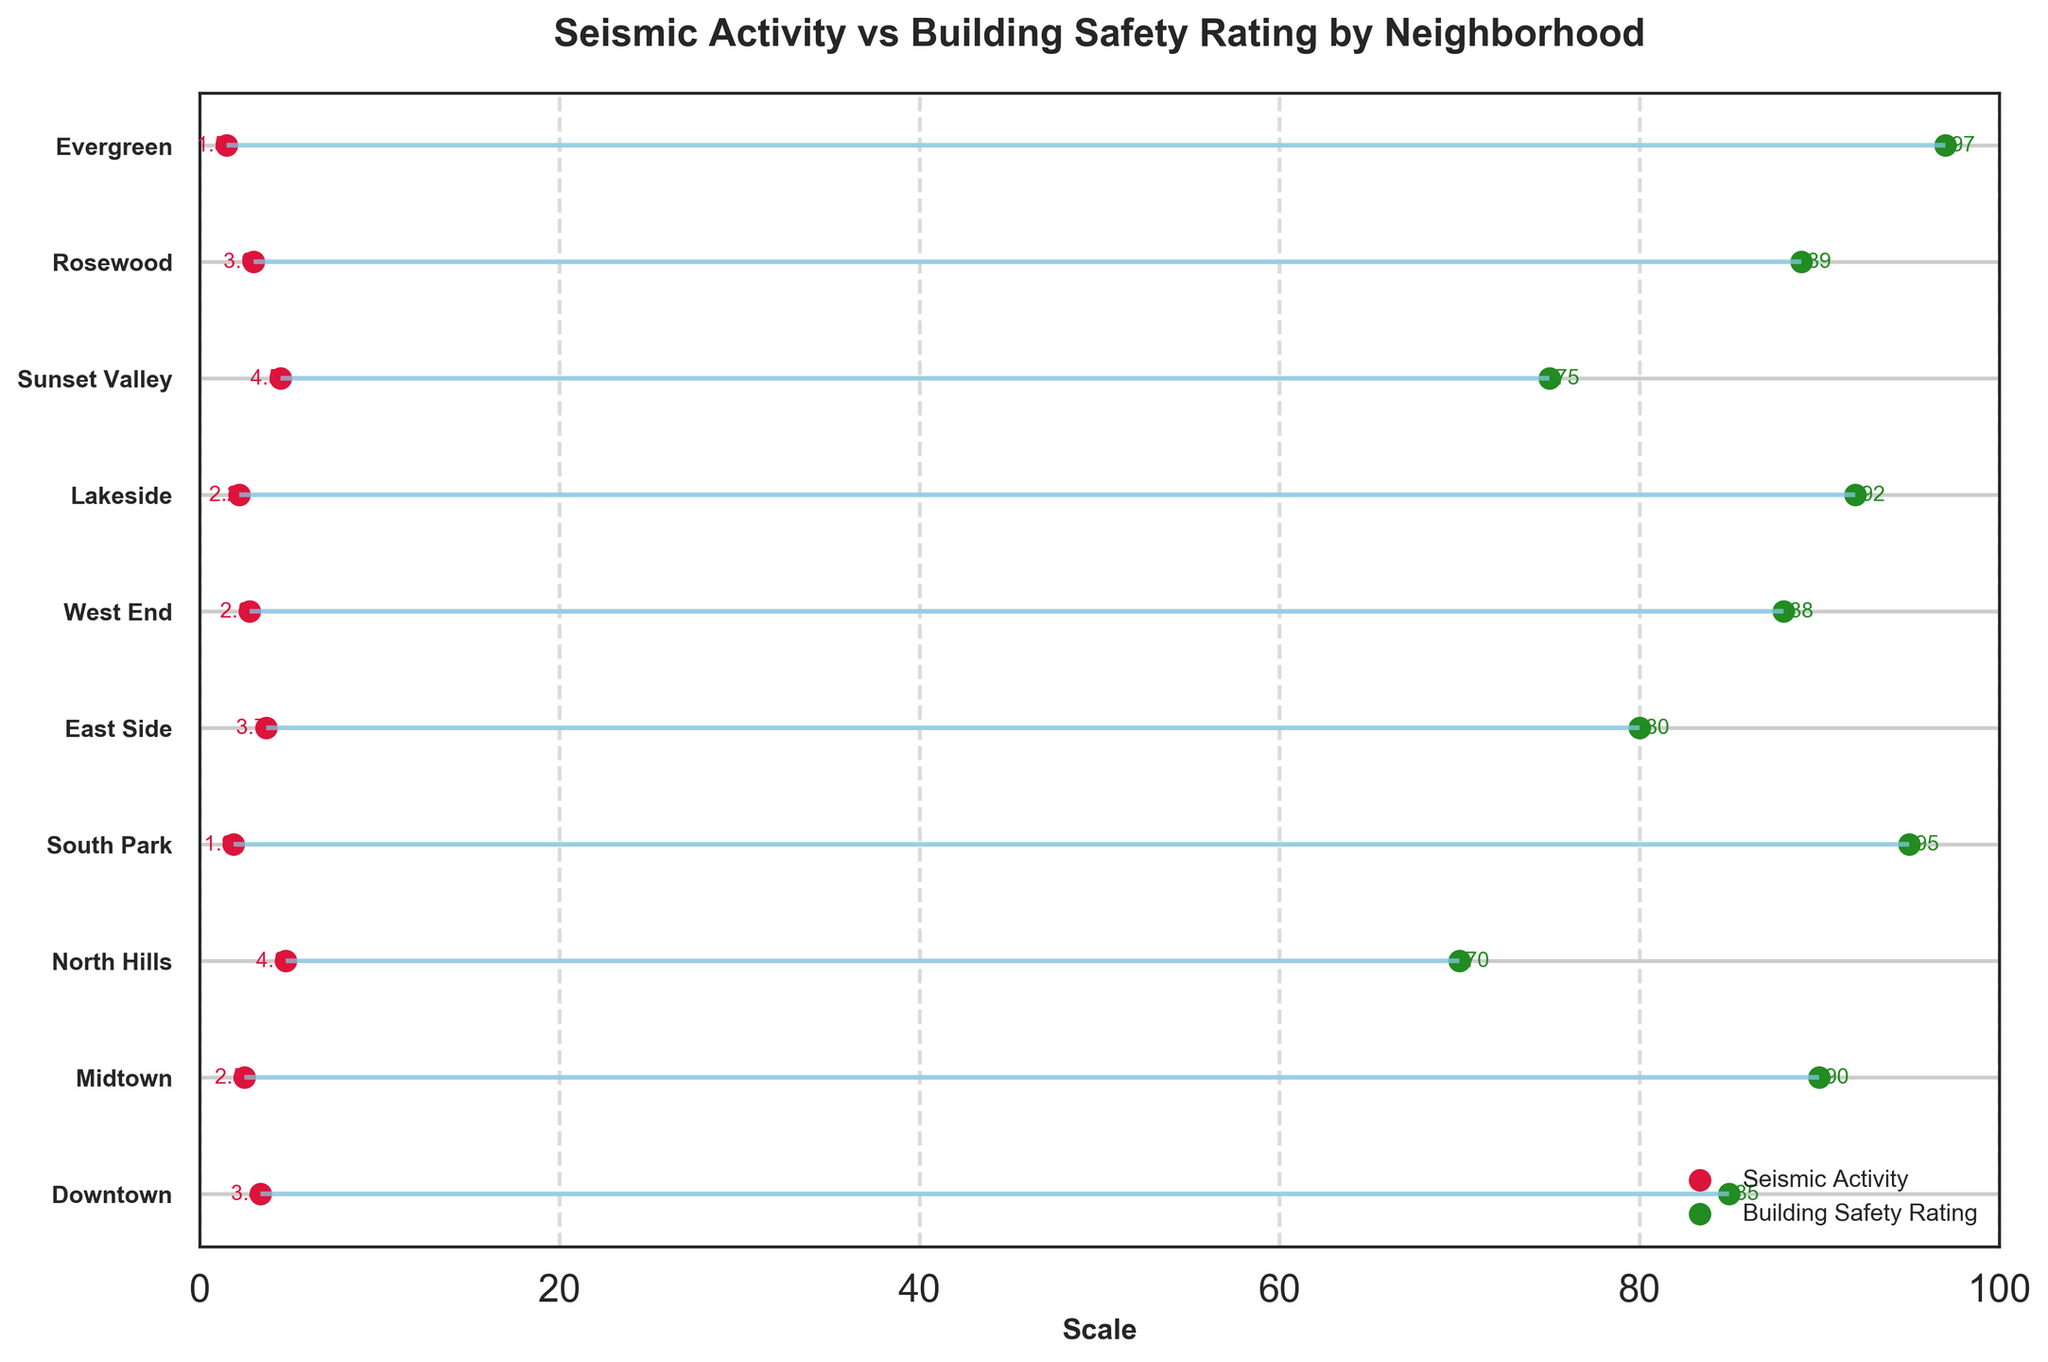What is the title of the plot? The title of the plot is usually found at the top center of the plot. In this case, the title "Seismic Activity vs Building Safety Rating by Neighborhood" is displayed.
Answer: Seismic Activity vs Building Safety Rating by Neighborhood How many neighborhoods are depicted in the plot? Count the number of labeled horizontal lines or data points in the plot. Each labeled line represents a neighborhood.
Answer: 10 Which neighborhood has the highest building safety rating? Look for the data point on the plot where the green dot is the farthest to the right along the x-axis and note the neighborhood label on the y-axis.
Answer: Evergreen What is the seismic activity rating for Downtown? Locate Downtown on the y-axis, then find the red dot corresponding to seismic activity next to it and read the value.
Answer: 3.4 Which neighborhood has the highest seismic activity? Identify the neighborhood where the red dot is the farthest to the right along the x-axis.
Answer: North Hills What is the difference between the building safety rating and seismic activity for North Hills? For North Hills, subtract the seismic activity rating (4.8) from the building safety rating (70) to find the difference.
Answer: 65 Which neighborhood has the smallest difference between building safety rating and seismic activity? Compare the distance between the red and green dots for each neighborhood to find the smallest gap. This involves identifying the neighborhood where the two dots are closest together.
Answer: Downtown How do the building safety ratings for Lakeside and East Side compare? Find the green dots for both Lakeside and East Side. Compare their positions on the x-axis to determine which is farther to the right.
Answer: Lakeside has a higher safety rating Which neighborhoods have building safety ratings above 90? Identify the green dots that exceed the 90 mark on the x-axis and check the corresponding neighborhoods.
Answer: Midtown, South Park, Lakeside, Evergreen 